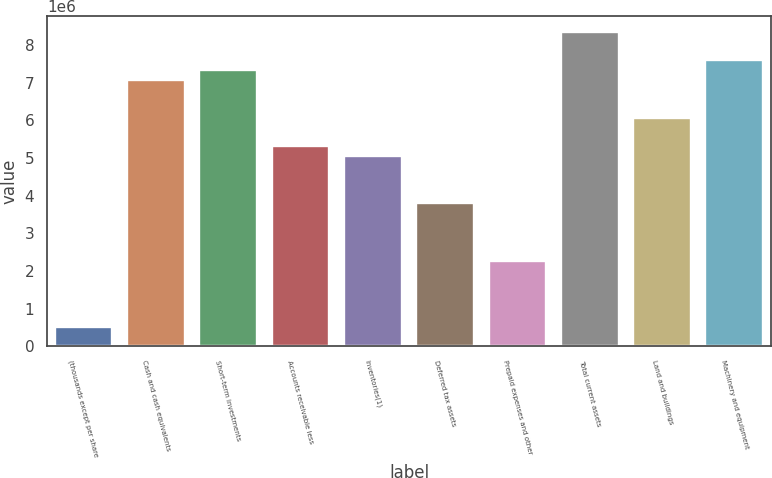Convert chart to OTSL. <chart><loc_0><loc_0><loc_500><loc_500><bar_chart><fcel>(thousands except per share<fcel>Cash and cash equivalents<fcel>Short-term investments<fcel>Accounts receivable less<fcel>Inventories(1)<fcel>Deferred tax assets<fcel>Prepaid expenses and other<fcel>Total current assets<fcel>Land and buildings<fcel>Machinery and equipment<nl><fcel>506906<fcel>7.0792e+06<fcel>7.33198e+06<fcel>5.30973e+06<fcel>5.05695e+06<fcel>3.79305e+06<fcel>2.27637e+06<fcel>8.3431e+06<fcel>6.06807e+06<fcel>7.58476e+06<nl></chart> 